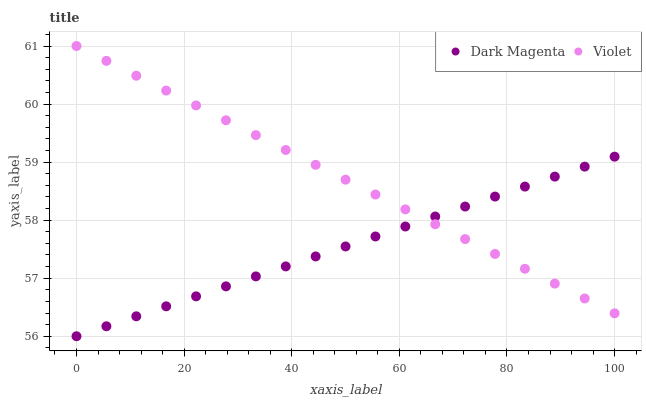Does Dark Magenta have the minimum area under the curve?
Answer yes or no. Yes. Does Violet have the maximum area under the curve?
Answer yes or no. Yes. Does Violet have the minimum area under the curve?
Answer yes or no. No. Is Violet the smoothest?
Answer yes or no. Yes. Is Dark Magenta the roughest?
Answer yes or no. Yes. Is Violet the roughest?
Answer yes or no. No. Does Dark Magenta have the lowest value?
Answer yes or no. Yes. Does Violet have the lowest value?
Answer yes or no. No. Does Violet have the highest value?
Answer yes or no. Yes. Does Dark Magenta intersect Violet?
Answer yes or no. Yes. Is Dark Magenta less than Violet?
Answer yes or no. No. Is Dark Magenta greater than Violet?
Answer yes or no. No. 